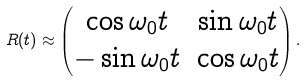Convert formula to latex. <formula><loc_0><loc_0><loc_500><loc_500>R ( t ) \approx \begin{pmatrix} \cos \omega _ { 0 } t & \sin \omega _ { 0 } t \\ - \sin \omega _ { 0 } t & \cos \omega _ { 0 } t \end{pmatrix} .</formula> 